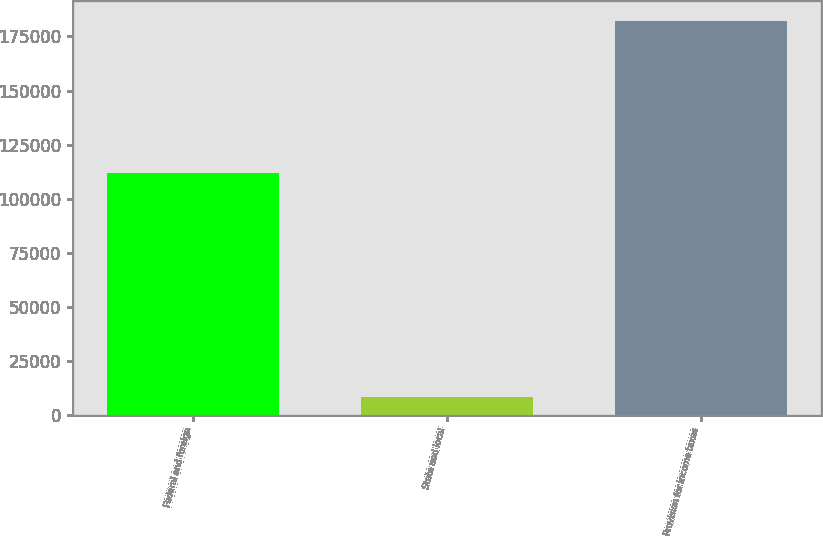Convert chart. <chart><loc_0><loc_0><loc_500><loc_500><bar_chart><fcel>Federal and foreign<fcel>State and local<fcel>Provision for income taxes<nl><fcel>111713<fcel>8442<fcel>182363<nl></chart> 